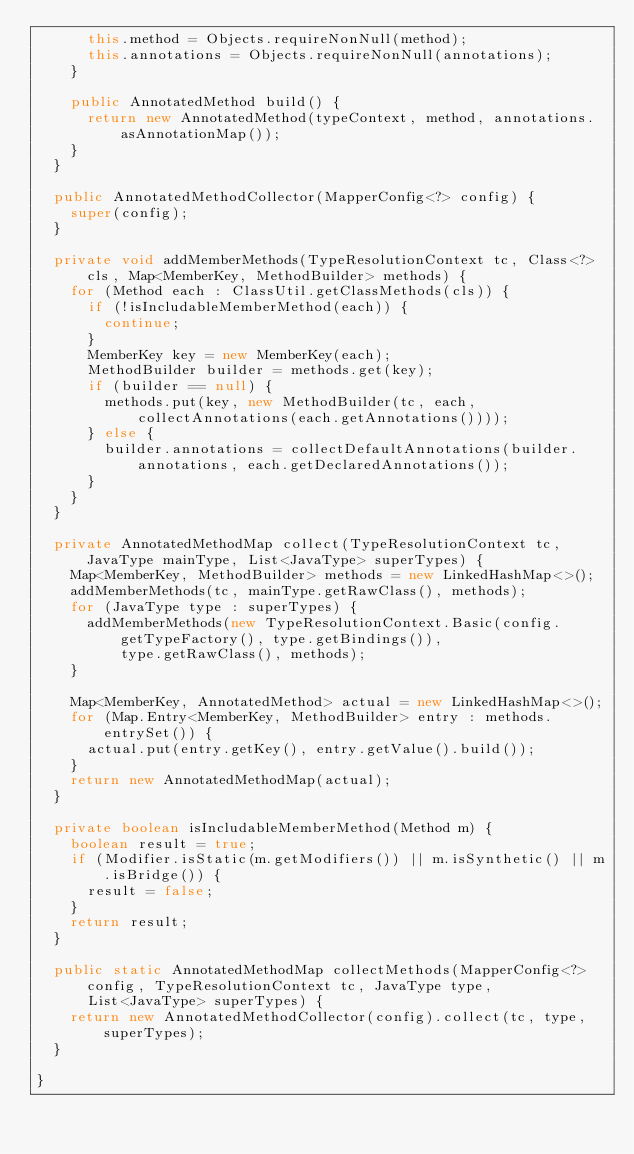<code> <loc_0><loc_0><loc_500><loc_500><_Java_>			this.method = Objects.requireNonNull(method);
			this.annotations = Objects.requireNonNull(annotations);
		}

		public AnnotatedMethod build() {
			return new AnnotatedMethod(typeContext, method, annotations.asAnnotationMap());
		}
	}

	public AnnotatedMethodCollector(MapperConfig<?> config) {
		super(config);
	}

	private void addMemberMethods(TypeResolutionContext tc, Class<?> cls, Map<MemberKey, MethodBuilder> methods) {
		for (Method each : ClassUtil.getClassMethods(cls)) {
			if (!isIncludableMemberMethod(each)) {
				continue;
			}
			MemberKey key = new MemberKey(each);
			MethodBuilder builder = methods.get(key);
			if (builder == null) {
				methods.put(key, new MethodBuilder(tc, each, collectAnnotations(each.getAnnotations())));
			} else {
				builder.annotations = collectDefaultAnnotations(builder.annotations, each.getDeclaredAnnotations());
			}
		}
	}

	private AnnotatedMethodMap collect(TypeResolutionContext tc, JavaType mainType, List<JavaType> superTypes) {
		Map<MemberKey, MethodBuilder> methods = new LinkedHashMap<>();
		addMemberMethods(tc, mainType.getRawClass(), methods);
		for (JavaType type : superTypes) {
			addMemberMethods(new TypeResolutionContext.Basic(config.getTypeFactory(), type.getBindings()),
					type.getRawClass(), methods);
		}

		Map<MemberKey, AnnotatedMethod> actual = new LinkedHashMap<>();
		for (Map.Entry<MemberKey, MethodBuilder> entry : methods.entrySet()) {
			actual.put(entry.getKey(), entry.getValue().build());
		}
		return new AnnotatedMethodMap(actual);
	}

	private boolean isIncludableMemberMethod(Method m) {
		boolean result = true;
		if (Modifier.isStatic(m.getModifiers()) || m.isSynthetic() || m.isBridge()) {
			result = false;
		}
		return result;
	}

	public static AnnotatedMethodMap collectMethods(MapperConfig<?> config, TypeResolutionContext tc, JavaType type,
			List<JavaType> superTypes) {
		return new AnnotatedMethodCollector(config).collect(tc, type, superTypes);
	}

}
</code> 